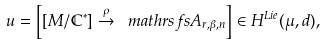<formula> <loc_0><loc_0><loc_500><loc_500>u = \left [ [ M / \mathbb { C } ^ { \ast } ] \stackrel { \rho } { \to } \ m a t h r s f s { A } _ { r , \beta , n } \right ] \in H ^ { L i e } ( \mu , d ) ,</formula> 